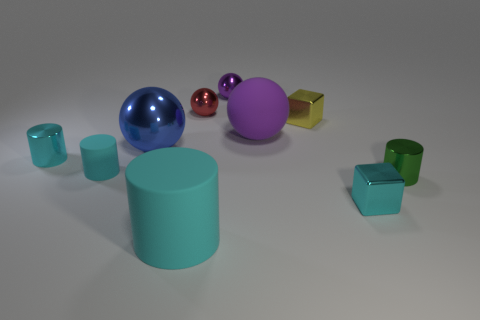What number of large red matte spheres are there?
Offer a terse response. 0. How many objects are large gray cubes or yellow cubes?
Make the answer very short. 1. What number of tiny green cylinders are on the left side of the purple thing that is in front of the tiny yellow block to the left of the green cylinder?
Your response must be concise. 0. Is there anything else that is the same color as the large metal thing?
Offer a very short reply. No. Is the color of the shiny cylinder behind the small green cylinder the same as the big rubber thing left of the tiny red metal object?
Offer a terse response. Yes. Are there more big cylinders to the left of the tiny rubber cylinder than big metal balls on the left side of the big metallic object?
Provide a short and direct response. No. What is the small red ball made of?
Your response must be concise. Metal. There is a cyan metallic thing on the left side of the big thing that is in front of the cyan metal object to the left of the tiny purple sphere; what shape is it?
Ensure brevity in your answer.  Cylinder. What number of other objects are the same material as the small red thing?
Your answer should be very brief. 6. Are the purple object in front of the tiny purple sphere and the cyan cylinder that is in front of the green cylinder made of the same material?
Keep it short and to the point. Yes. 